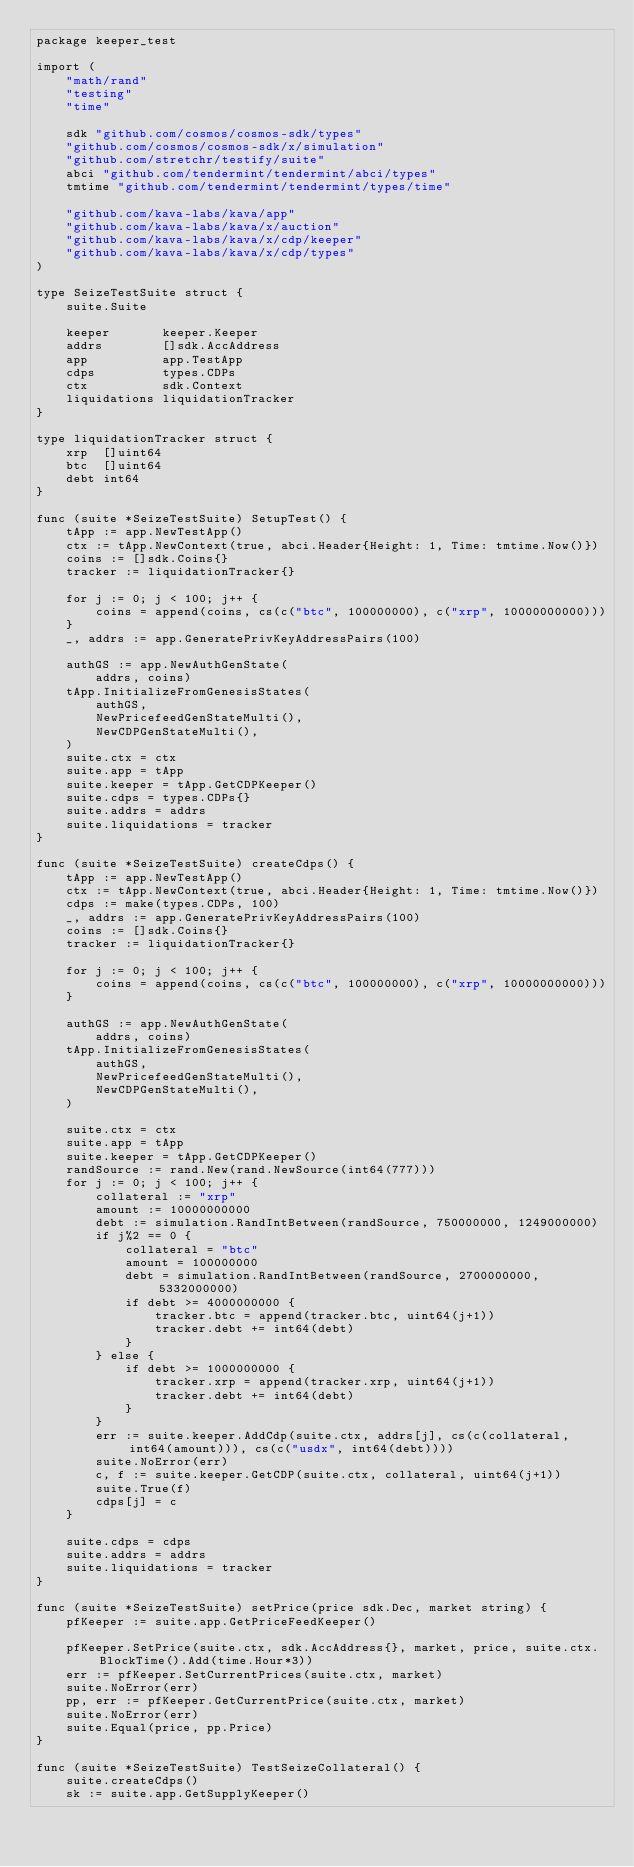<code> <loc_0><loc_0><loc_500><loc_500><_Go_>package keeper_test

import (
	"math/rand"
	"testing"
	"time"

	sdk "github.com/cosmos/cosmos-sdk/types"
	"github.com/cosmos/cosmos-sdk/x/simulation"
	"github.com/stretchr/testify/suite"
	abci "github.com/tendermint/tendermint/abci/types"
	tmtime "github.com/tendermint/tendermint/types/time"

	"github.com/kava-labs/kava/app"
	"github.com/kava-labs/kava/x/auction"
	"github.com/kava-labs/kava/x/cdp/keeper"
	"github.com/kava-labs/kava/x/cdp/types"
)

type SeizeTestSuite struct {
	suite.Suite

	keeper       keeper.Keeper
	addrs        []sdk.AccAddress
	app          app.TestApp
	cdps         types.CDPs
	ctx          sdk.Context
	liquidations liquidationTracker
}

type liquidationTracker struct {
	xrp  []uint64
	btc  []uint64
	debt int64
}

func (suite *SeizeTestSuite) SetupTest() {
	tApp := app.NewTestApp()
	ctx := tApp.NewContext(true, abci.Header{Height: 1, Time: tmtime.Now()})
	coins := []sdk.Coins{}
	tracker := liquidationTracker{}

	for j := 0; j < 100; j++ {
		coins = append(coins, cs(c("btc", 100000000), c("xrp", 10000000000)))
	}
	_, addrs := app.GeneratePrivKeyAddressPairs(100)

	authGS := app.NewAuthGenState(
		addrs, coins)
	tApp.InitializeFromGenesisStates(
		authGS,
		NewPricefeedGenStateMulti(),
		NewCDPGenStateMulti(),
	)
	suite.ctx = ctx
	suite.app = tApp
	suite.keeper = tApp.GetCDPKeeper()
	suite.cdps = types.CDPs{}
	suite.addrs = addrs
	suite.liquidations = tracker
}

func (suite *SeizeTestSuite) createCdps() {
	tApp := app.NewTestApp()
	ctx := tApp.NewContext(true, abci.Header{Height: 1, Time: tmtime.Now()})
	cdps := make(types.CDPs, 100)
	_, addrs := app.GeneratePrivKeyAddressPairs(100)
	coins := []sdk.Coins{}
	tracker := liquidationTracker{}

	for j := 0; j < 100; j++ {
		coins = append(coins, cs(c("btc", 100000000), c("xrp", 10000000000)))
	}

	authGS := app.NewAuthGenState(
		addrs, coins)
	tApp.InitializeFromGenesisStates(
		authGS,
		NewPricefeedGenStateMulti(),
		NewCDPGenStateMulti(),
	)

	suite.ctx = ctx
	suite.app = tApp
	suite.keeper = tApp.GetCDPKeeper()
	randSource := rand.New(rand.NewSource(int64(777)))
	for j := 0; j < 100; j++ {
		collateral := "xrp"
		amount := 10000000000
		debt := simulation.RandIntBetween(randSource, 750000000, 1249000000)
		if j%2 == 0 {
			collateral = "btc"
			amount = 100000000
			debt = simulation.RandIntBetween(randSource, 2700000000, 5332000000)
			if debt >= 4000000000 {
				tracker.btc = append(tracker.btc, uint64(j+1))
				tracker.debt += int64(debt)
			}
		} else {
			if debt >= 1000000000 {
				tracker.xrp = append(tracker.xrp, uint64(j+1))
				tracker.debt += int64(debt)
			}
		}
		err := suite.keeper.AddCdp(suite.ctx, addrs[j], cs(c(collateral, int64(amount))), cs(c("usdx", int64(debt))))
		suite.NoError(err)
		c, f := suite.keeper.GetCDP(suite.ctx, collateral, uint64(j+1))
		suite.True(f)
		cdps[j] = c
	}

	suite.cdps = cdps
	suite.addrs = addrs
	suite.liquidations = tracker
}

func (suite *SeizeTestSuite) setPrice(price sdk.Dec, market string) {
	pfKeeper := suite.app.GetPriceFeedKeeper()

	pfKeeper.SetPrice(suite.ctx, sdk.AccAddress{}, market, price, suite.ctx.BlockTime().Add(time.Hour*3))
	err := pfKeeper.SetCurrentPrices(suite.ctx, market)
	suite.NoError(err)
	pp, err := pfKeeper.GetCurrentPrice(suite.ctx, market)
	suite.NoError(err)
	suite.Equal(price, pp.Price)
}

func (suite *SeizeTestSuite) TestSeizeCollateral() {
	suite.createCdps()
	sk := suite.app.GetSupplyKeeper()</code> 